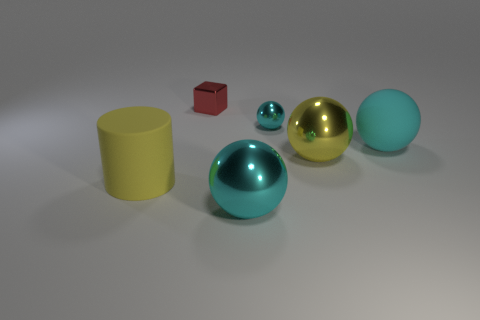How many cyan balls must be subtracted to get 1 cyan balls? 2 Subtract all large spheres. How many spheres are left? 1 Subtract all brown blocks. How many cyan balls are left? 3 Subtract 2 spheres. How many spheres are left? 2 Add 3 yellow balls. How many objects exist? 9 Subtract all yellow spheres. How many spheres are left? 3 Subtract all cylinders. How many objects are left? 5 Subtract all blue balls. Subtract all yellow cubes. How many balls are left? 4 Add 6 purple metallic cylinders. How many purple metallic cylinders exist? 6 Subtract 1 cyan spheres. How many objects are left? 5 